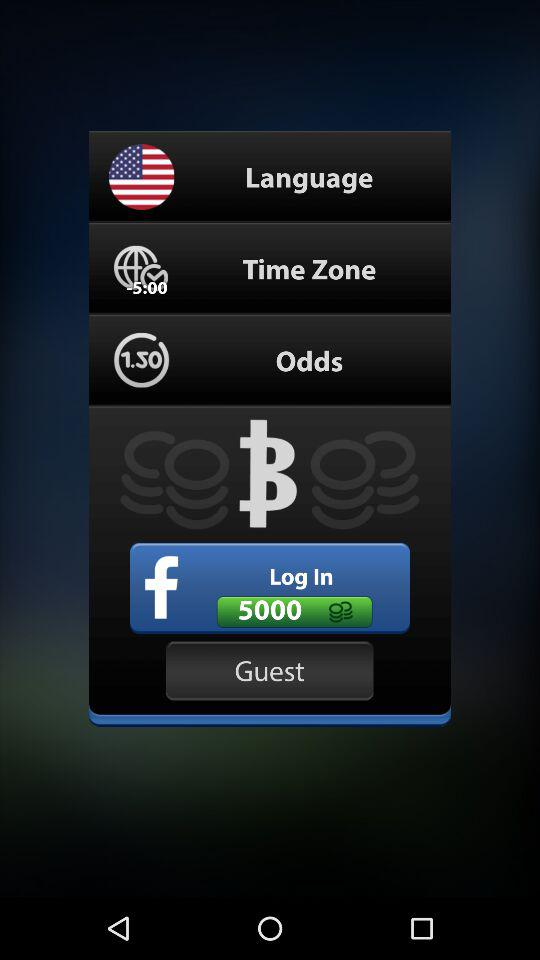What application can we use to log in? You can use "Facebook" to log in. 